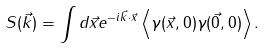Convert formula to latex. <formula><loc_0><loc_0><loc_500><loc_500>S ( \vec { k } ) = \int d \vec { x } e ^ { - i \vec { k } \cdot \vec { x } } \left < \gamma ( \vec { x } , 0 ) \gamma ( \vec { 0 } , 0 ) \right > .</formula> 